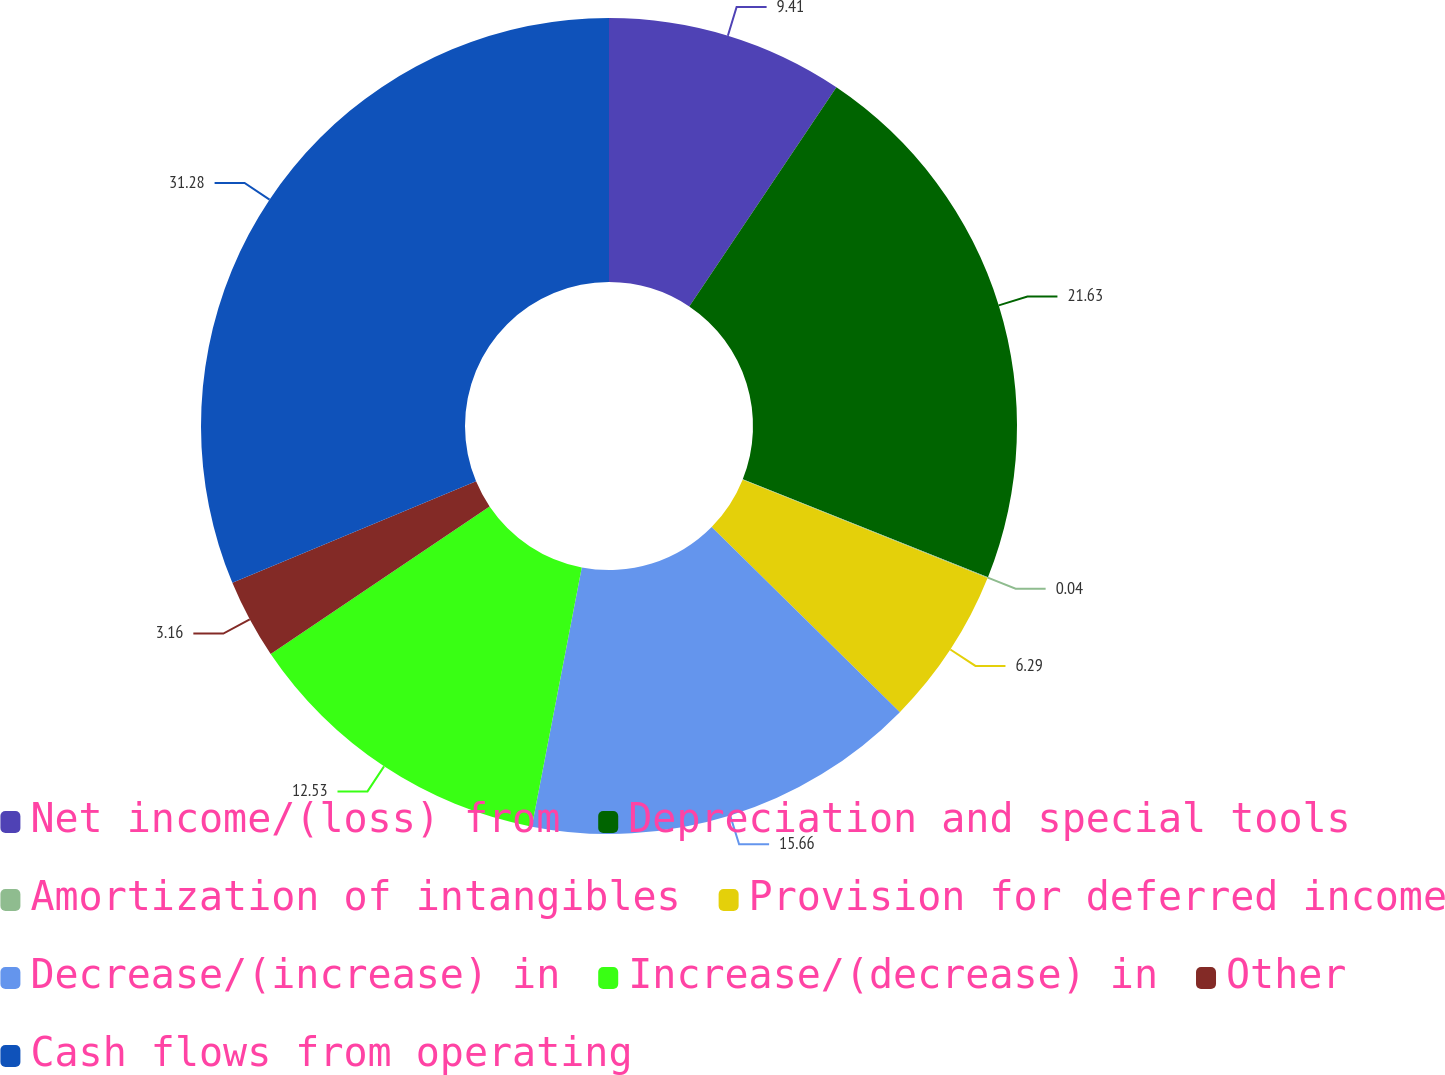Convert chart. <chart><loc_0><loc_0><loc_500><loc_500><pie_chart><fcel>Net income/(loss) from<fcel>Depreciation and special tools<fcel>Amortization of intangibles<fcel>Provision for deferred income<fcel>Decrease/(increase) in<fcel>Increase/(decrease) in<fcel>Other<fcel>Cash flows from operating<nl><fcel>9.41%<fcel>21.63%<fcel>0.04%<fcel>6.29%<fcel>15.66%<fcel>12.53%<fcel>3.16%<fcel>31.28%<nl></chart> 